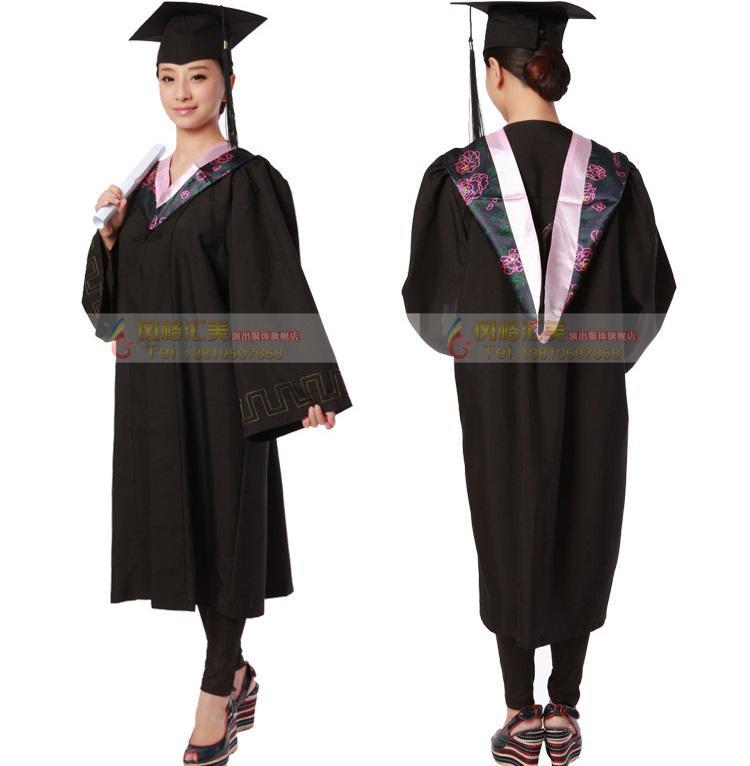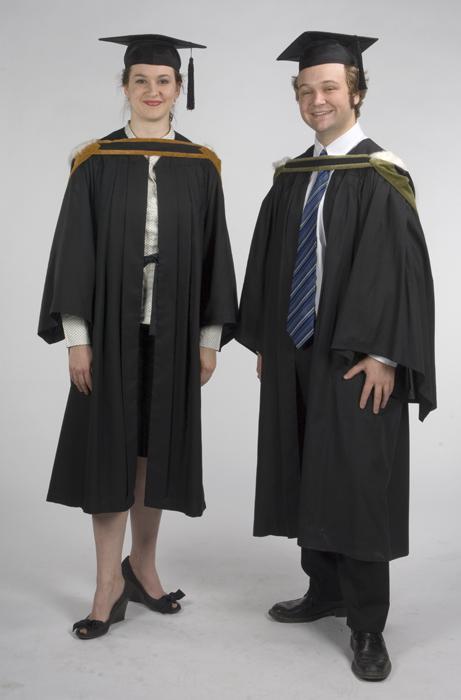The first image is the image on the left, the second image is the image on the right. Examine the images to the left and right. Is the description "There are exactly two people shown in both of the images." accurate? Answer yes or no. Yes. The first image is the image on the left, the second image is the image on the right. For the images displayed, is the sentence "An image shows front and rear views of a graduation model." factually correct? Answer yes or no. Yes. The first image is the image on the left, the second image is the image on the right. For the images displayed, is the sentence "There are exactly two people in the image on the right." factually correct? Answer yes or no. Yes. 